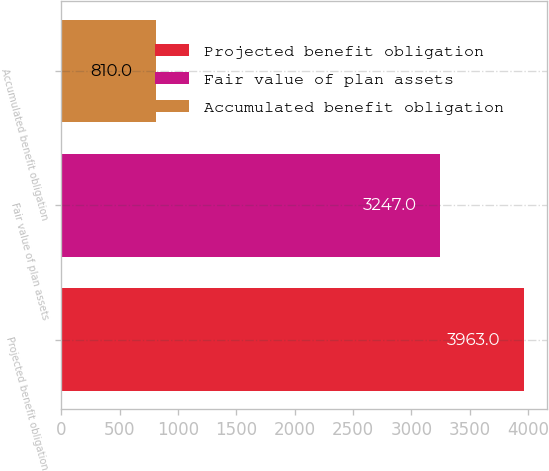<chart> <loc_0><loc_0><loc_500><loc_500><bar_chart><fcel>Projected benefit obligation<fcel>Fair value of plan assets<fcel>Accumulated benefit obligation<nl><fcel>3963<fcel>3247<fcel>810<nl></chart> 